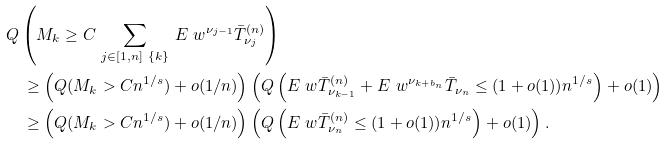Convert formula to latex. <formula><loc_0><loc_0><loc_500><loc_500>& Q \left ( M _ { k } \geq C \, \sum _ { j \in [ 1 , n ] \ \{ k \} } \, E _ { \ } w ^ { \nu _ { j - 1 } } \bar { T } _ { \nu _ { j } } ^ { ( n ) } \right ) \\ & \quad \geq \left ( Q ( M _ { k } > C n ^ { 1 / s } ) + o ( 1 / n ) \right ) \left ( Q \left ( E _ { \ } w \bar { T } _ { \nu _ { k - 1 } } ^ { ( n ) } + E _ { \ } w ^ { \nu _ { k + b _ { n } } } \bar { T } _ { \nu _ { n } } \leq ( 1 + o ( 1 ) ) n ^ { 1 / s } \right ) + o ( 1 ) \right ) \\ & \quad \geq \left ( Q ( M _ { k } > C n ^ { 1 / s } ) + o ( 1 / n ) \right ) \left ( Q \left ( E _ { \ } w \bar { T } _ { \nu _ { n } } ^ { ( n ) } \leq ( 1 + o ( 1 ) ) n ^ { 1 / s } \right ) + o ( 1 ) \right ) .</formula> 